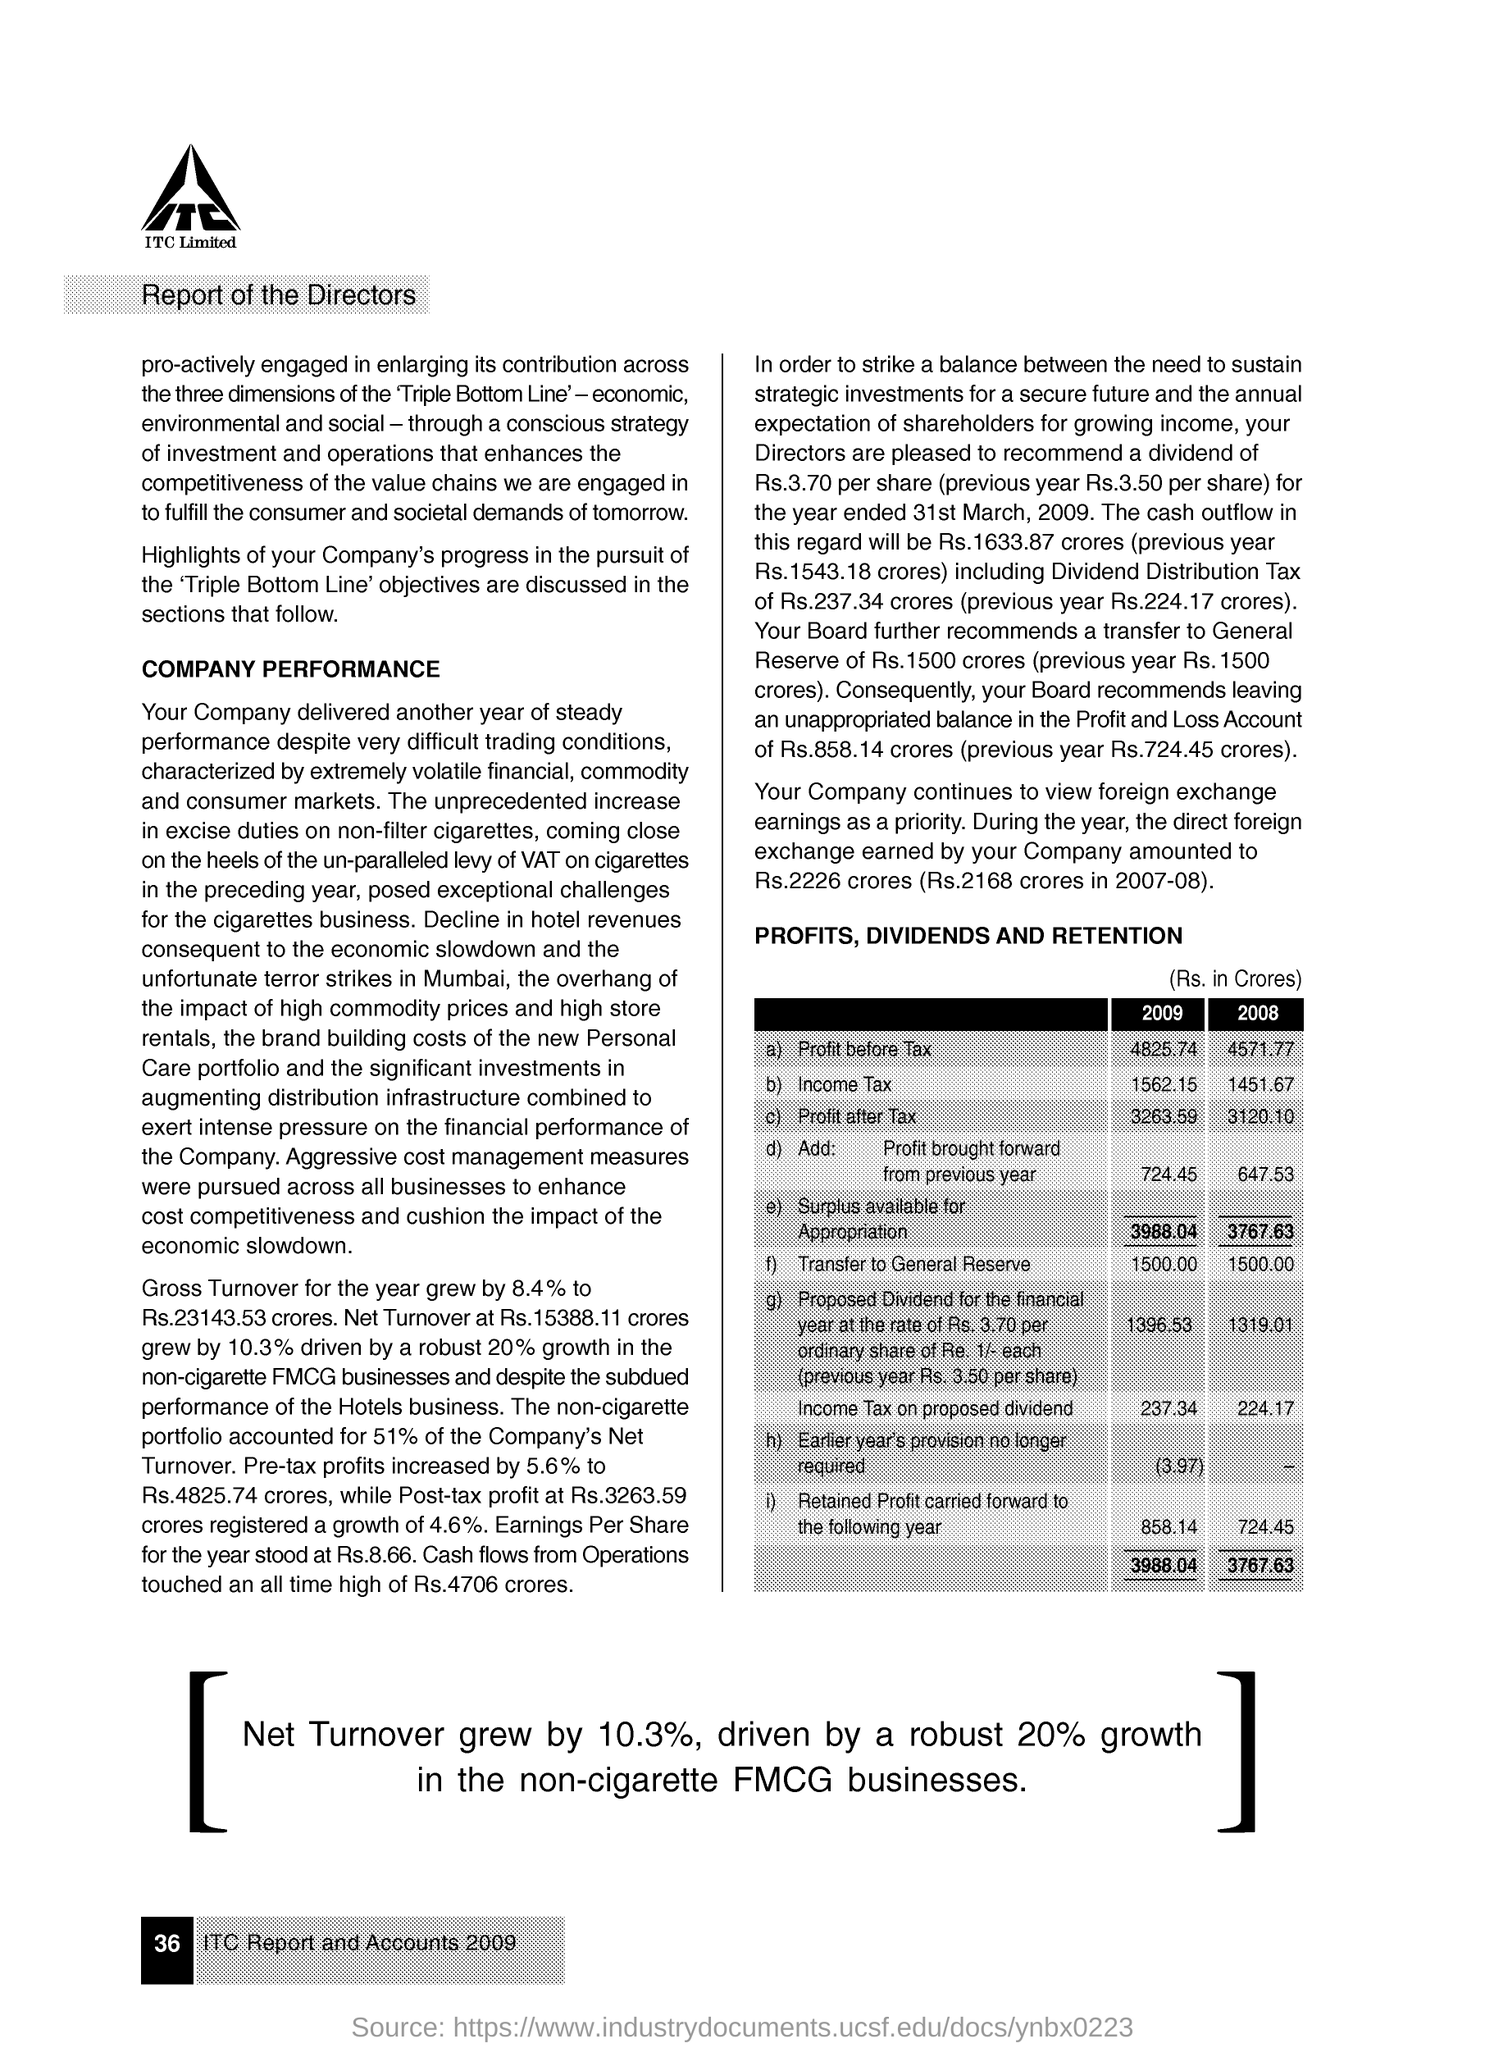What is net growth in turnover?
Provide a succinct answer. 10.3%. What is income tax in 2008?
Offer a terse response. 1451.67. What is profit before tax in 2009?
Your answer should be compact. 4825.74. 